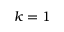<formula> <loc_0><loc_0><loc_500><loc_500>k = 1</formula> 